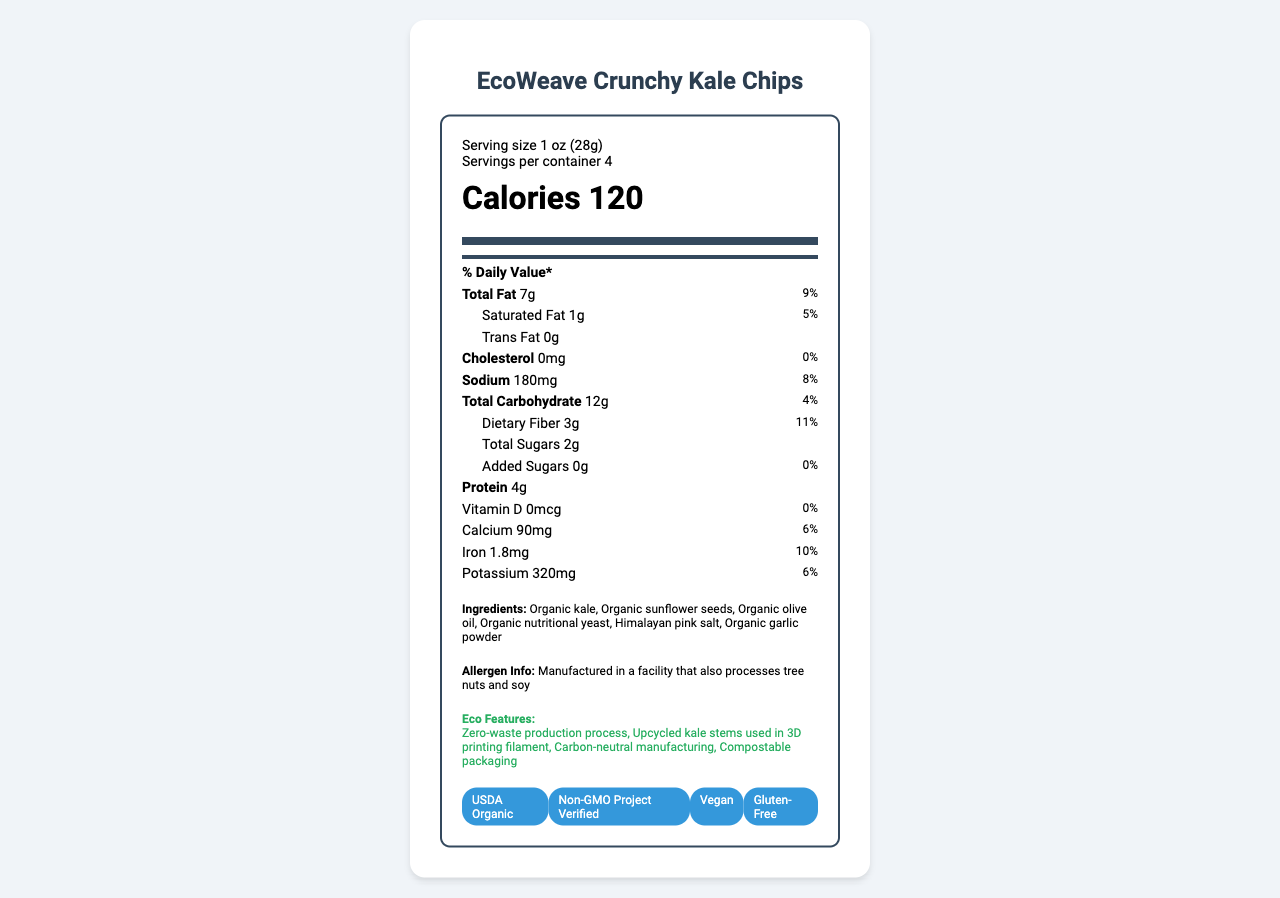what is the serving size? The serving size is clearly listed under the "Serving size" section.
Answer: 1 oz (28g) how many calories are in one serving? The calories per serving are indicated in the "Calories" section.
Answer: 120 how much dietary fiber is in each serving? The amount of dietary fiber per serving is listed under "Dietary Fiber".
Answer: 3g how much sodium does each serving contain? The sodium content per serving is specified in the "Sodium" section.
Answer: 180mg what are the first three ingredients listed? The ingredients are listed in order from the most to least present; the first three are "Organic kale", "Organic sunflower seeds", and "Organic olive oil".
Answer: Organic kale, Organic sunflower seeds, Organic olive oil which certification denotes that the product is free from genetically modified organisms (GMOs)? A. USDA Organic B. Non-GMO Project Verified C. Vegan D. Gluten-Free The certification "Non-GMO Project Verified" indicates that the product is free from GMOs.
Answer: B. Non-GMO Project Verified which nutrient has the highest daily value percentage? A. Total Fat B. Dietary Fiber C. Iron D. Protein The daily value percentage for Dietary Fiber is 11%, which is the highest compared to others listed.
Answer: B. Dietary Fiber is this snack high in trans fat? The document shows that the amount of trans fat is 0g.
Answer: No summarize the main idea of this document. The document includes details about the serving size, calorie content, various nutrient amounts, eco-friendly packaging, ingredients list, and certifications for the product.
Answer: The document provides detailed nutritional information, ingredients, eco-friendly packaging, certifications, and allergen information for EcoWeave Crunchy Kale Chips. what is the bar code number for this product? The barcode number is listed at the bottom of the document.
Answer: 8541962730154 how much calcium is in one serving? The calcium content per serving is specified under "Calcium".
Answer: 90mg can any information about sugar substitutes be found in the document? The document does not provide information about sugar substitutes directly.
Answer: I don't know what type of packaging is used for this product? The document mentions that the product is packaged in a 3D-printed biodegradable PLA container derived from corn starch.
Answer: 3D-printed biodegradable PLA container derived from corn starch what is the allergen information provided? The allergen information states that the product is manufactured in a facility that also processes tree nuts and soy.
Answer: Manufactured in a facility that also processes tree nuts and soy are iron and potassium mentioned in the eco features section? Iron and potassium are listed under nutrients, not under the eco features.
Answer: No 